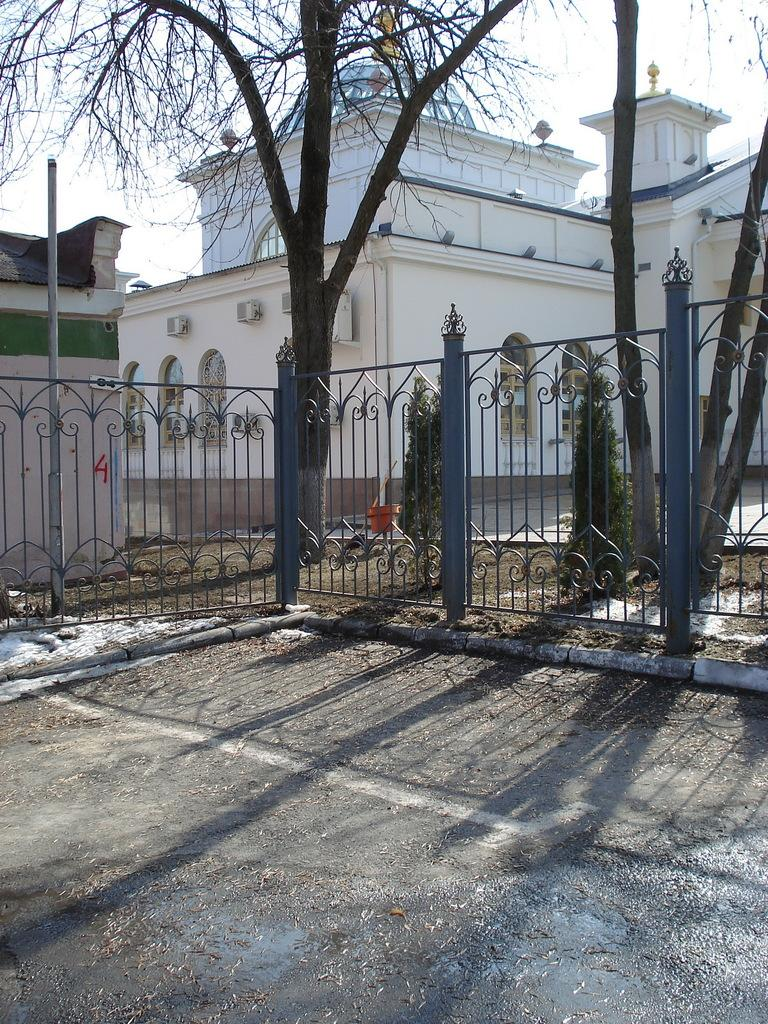What color is the fencing in the image? The fencing in the image is grey. What is the color of the building behind the fencing? The building behind the fencing is white. Are there any plants or vegetation in the image? Yes, there is a tree present in the image. What type of copper material is used for the tree in the image? There is no copper material used for the tree in the image; it is a natural tree. What polish is applied to the white building in the image? There is no mention of any polish being applied to the white building in the image. 